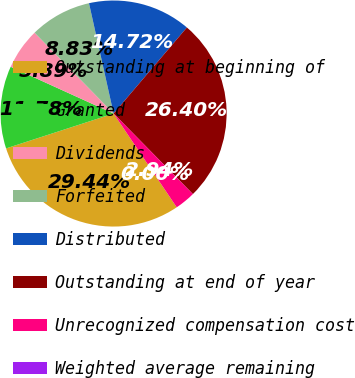<chart> <loc_0><loc_0><loc_500><loc_500><pie_chart><fcel>Outstanding at beginning of<fcel>Granted<fcel>Dividends<fcel>Forfeited<fcel>Distributed<fcel>Outstanding at end of year<fcel>Unrecognized compensation cost<fcel>Weighted average remaining<nl><fcel>29.44%<fcel>11.78%<fcel>5.89%<fcel>8.83%<fcel>14.72%<fcel>26.4%<fcel>2.94%<fcel>0.0%<nl></chart> 